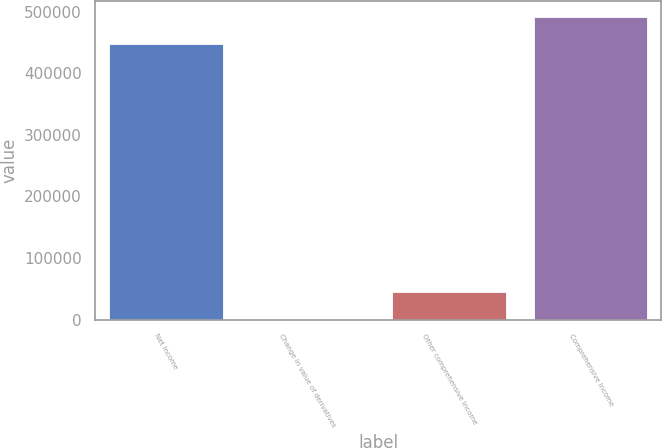Convert chart to OTSL. <chart><loc_0><loc_0><loc_500><loc_500><bar_chart><fcel>Net income<fcel>Change in value of derivatives<fcel>Other comprehensive income<fcel>Comprehensive income<nl><fcel>447221<fcel>81<fcel>44803.1<fcel>491943<nl></chart> 